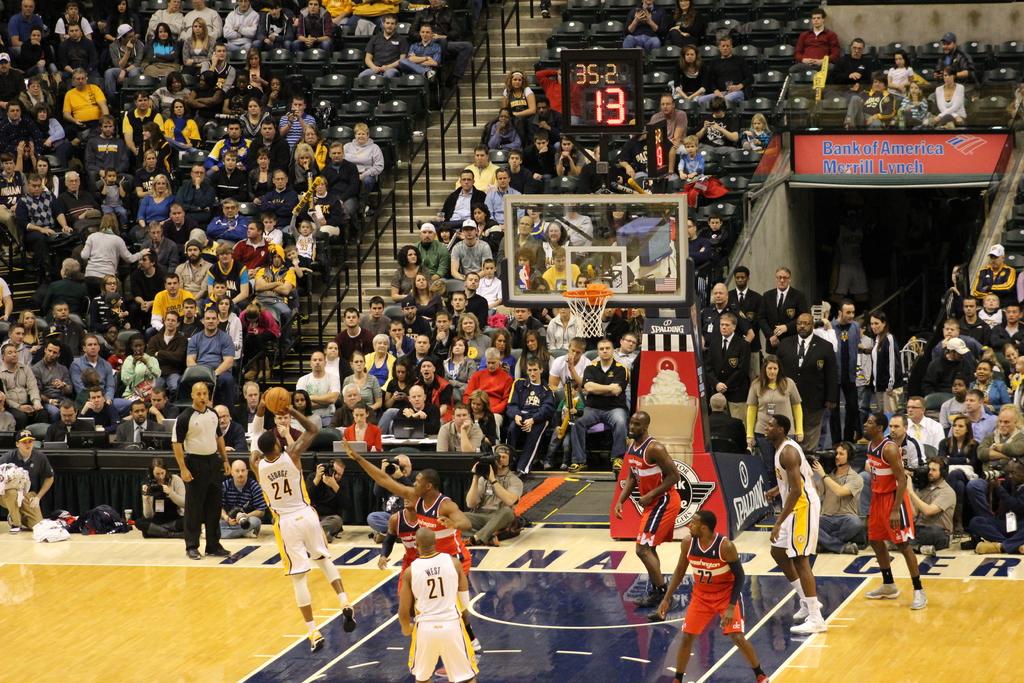What number is the player who has the ball?
Offer a terse response. 24. How many seconds are left on the shot clock?
Your answer should be very brief. 13. 